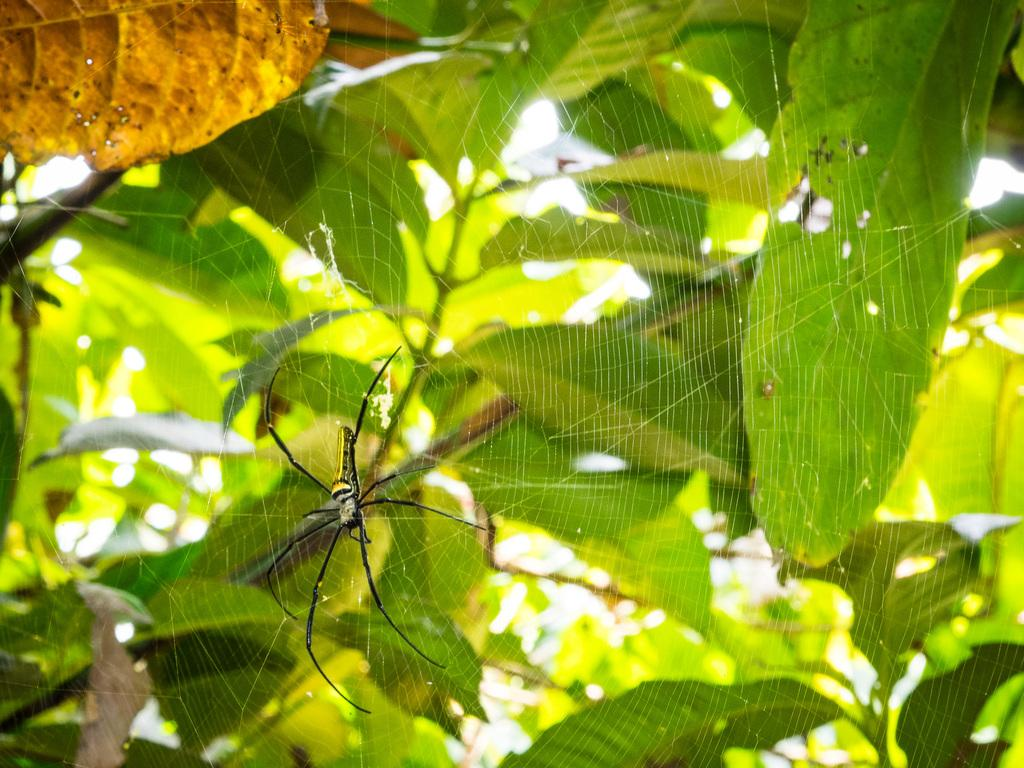What is present in the image? There is a tree in the image. Can you describe the tree further? There is a spider on the tree and a spider web on the tree. What type of skin condition can be seen on the spider in the image? There is no indication of a skin condition on the spider in the image, as spiders do not have skin like humans. 